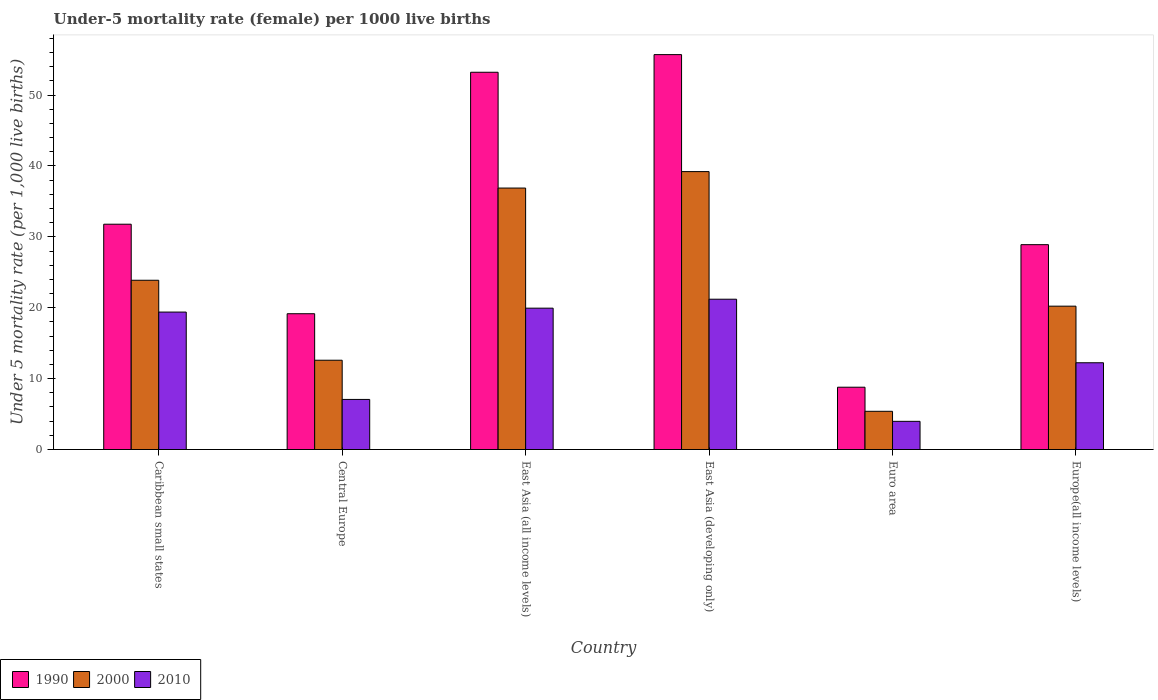How many groups of bars are there?
Make the answer very short. 6. Are the number of bars per tick equal to the number of legend labels?
Make the answer very short. Yes. How many bars are there on the 3rd tick from the left?
Keep it short and to the point. 3. How many bars are there on the 1st tick from the right?
Your response must be concise. 3. What is the label of the 4th group of bars from the left?
Your answer should be compact. East Asia (developing only). In how many cases, is the number of bars for a given country not equal to the number of legend labels?
Your answer should be very brief. 0. What is the under-five mortality rate in 1990 in Europe(all income levels)?
Ensure brevity in your answer.  28.9. Across all countries, what is the maximum under-five mortality rate in 1990?
Offer a very short reply. 55.7. Across all countries, what is the minimum under-five mortality rate in 2000?
Provide a short and direct response. 5.39. In which country was the under-five mortality rate in 1990 maximum?
Provide a succinct answer. East Asia (developing only). In which country was the under-five mortality rate in 2000 minimum?
Keep it short and to the point. Euro area. What is the total under-five mortality rate in 2000 in the graph?
Make the answer very short. 138.16. What is the difference between the under-five mortality rate in 1990 in Euro area and that in Europe(all income levels)?
Provide a succinct answer. -20.11. What is the difference between the under-five mortality rate in 2010 in East Asia (developing only) and the under-five mortality rate in 1990 in Euro area?
Ensure brevity in your answer.  12.41. What is the average under-five mortality rate in 2000 per country?
Your answer should be very brief. 23.03. What is the difference between the under-five mortality rate of/in 1990 and under-five mortality rate of/in 2000 in Europe(all income levels)?
Give a very brief answer. 8.68. In how many countries, is the under-five mortality rate in 2000 greater than 36?
Ensure brevity in your answer.  2. What is the ratio of the under-five mortality rate in 2010 in East Asia (all income levels) to that in Euro area?
Keep it short and to the point. 5.02. Is the under-five mortality rate in 1990 in Central Europe less than that in Europe(all income levels)?
Provide a short and direct response. Yes. What is the difference between the highest and the second highest under-five mortality rate in 1990?
Offer a terse response. -21.43. What is the difference between the highest and the lowest under-five mortality rate in 1990?
Give a very brief answer. 46.91. In how many countries, is the under-five mortality rate in 2000 greater than the average under-five mortality rate in 2000 taken over all countries?
Your answer should be compact. 3. What does the 2nd bar from the left in East Asia (all income levels) represents?
Offer a very short reply. 2000. What does the 3rd bar from the right in Central Europe represents?
Provide a short and direct response. 1990. Is it the case that in every country, the sum of the under-five mortality rate in 2000 and under-five mortality rate in 1990 is greater than the under-five mortality rate in 2010?
Make the answer very short. Yes. How many bars are there?
Provide a short and direct response. 18. How many countries are there in the graph?
Give a very brief answer. 6. What is the difference between two consecutive major ticks on the Y-axis?
Make the answer very short. 10. Does the graph contain any zero values?
Your answer should be compact. No. Does the graph contain grids?
Your answer should be compact. No. Where does the legend appear in the graph?
Keep it short and to the point. Bottom left. What is the title of the graph?
Offer a terse response. Under-5 mortality rate (female) per 1000 live births. Does "2005" appear as one of the legend labels in the graph?
Your answer should be compact. No. What is the label or title of the X-axis?
Your answer should be compact. Country. What is the label or title of the Y-axis?
Your answer should be compact. Under 5 mortality rate (per 1,0 live births). What is the Under 5 mortality rate (per 1,000 live births) in 1990 in Caribbean small states?
Give a very brief answer. 31.78. What is the Under 5 mortality rate (per 1,000 live births) in 2000 in Caribbean small states?
Give a very brief answer. 23.87. What is the Under 5 mortality rate (per 1,000 live births) in 2010 in Caribbean small states?
Your response must be concise. 19.39. What is the Under 5 mortality rate (per 1,000 live births) in 1990 in Central Europe?
Make the answer very short. 19.15. What is the Under 5 mortality rate (per 1,000 live births) in 2000 in Central Europe?
Provide a short and direct response. 12.6. What is the Under 5 mortality rate (per 1,000 live births) of 2010 in Central Europe?
Offer a very short reply. 7.06. What is the Under 5 mortality rate (per 1,000 live births) in 1990 in East Asia (all income levels)?
Your answer should be compact. 53.21. What is the Under 5 mortality rate (per 1,000 live births) of 2000 in East Asia (all income levels)?
Your response must be concise. 36.88. What is the Under 5 mortality rate (per 1,000 live births) in 2010 in East Asia (all income levels)?
Offer a terse response. 19.94. What is the Under 5 mortality rate (per 1,000 live births) in 1990 in East Asia (developing only)?
Give a very brief answer. 55.7. What is the Under 5 mortality rate (per 1,000 live births) in 2000 in East Asia (developing only)?
Provide a succinct answer. 39.2. What is the Under 5 mortality rate (per 1,000 live births) of 2010 in East Asia (developing only)?
Offer a terse response. 21.2. What is the Under 5 mortality rate (per 1,000 live births) in 1990 in Euro area?
Provide a succinct answer. 8.79. What is the Under 5 mortality rate (per 1,000 live births) of 2000 in Euro area?
Offer a very short reply. 5.39. What is the Under 5 mortality rate (per 1,000 live births) in 2010 in Euro area?
Keep it short and to the point. 3.97. What is the Under 5 mortality rate (per 1,000 live births) in 1990 in Europe(all income levels)?
Your response must be concise. 28.9. What is the Under 5 mortality rate (per 1,000 live births) in 2000 in Europe(all income levels)?
Provide a succinct answer. 20.22. What is the Under 5 mortality rate (per 1,000 live births) in 2010 in Europe(all income levels)?
Provide a short and direct response. 12.24. Across all countries, what is the maximum Under 5 mortality rate (per 1,000 live births) in 1990?
Keep it short and to the point. 55.7. Across all countries, what is the maximum Under 5 mortality rate (per 1,000 live births) of 2000?
Make the answer very short. 39.2. Across all countries, what is the maximum Under 5 mortality rate (per 1,000 live births) in 2010?
Ensure brevity in your answer.  21.2. Across all countries, what is the minimum Under 5 mortality rate (per 1,000 live births) of 1990?
Offer a very short reply. 8.79. Across all countries, what is the minimum Under 5 mortality rate (per 1,000 live births) in 2000?
Your response must be concise. 5.39. Across all countries, what is the minimum Under 5 mortality rate (per 1,000 live births) in 2010?
Keep it short and to the point. 3.97. What is the total Under 5 mortality rate (per 1,000 live births) in 1990 in the graph?
Your response must be concise. 197.53. What is the total Under 5 mortality rate (per 1,000 live births) of 2000 in the graph?
Make the answer very short. 138.16. What is the total Under 5 mortality rate (per 1,000 live births) in 2010 in the graph?
Provide a short and direct response. 83.8. What is the difference between the Under 5 mortality rate (per 1,000 live births) in 1990 in Caribbean small states and that in Central Europe?
Offer a terse response. 12.63. What is the difference between the Under 5 mortality rate (per 1,000 live births) in 2000 in Caribbean small states and that in Central Europe?
Keep it short and to the point. 11.28. What is the difference between the Under 5 mortality rate (per 1,000 live births) in 2010 in Caribbean small states and that in Central Europe?
Your answer should be compact. 12.32. What is the difference between the Under 5 mortality rate (per 1,000 live births) of 1990 in Caribbean small states and that in East Asia (all income levels)?
Your answer should be very brief. -21.43. What is the difference between the Under 5 mortality rate (per 1,000 live births) in 2000 in Caribbean small states and that in East Asia (all income levels)?
Provide a short and direct response. -13. What is the difference between the Under 5 mortality rate (per 1,000 live births) in 2010 in Caribbean small states and that in East Asia (all income levels)?
Provide a short and direct response. -0.55. What is the difference between the Under 5 mortality rate (per 1,000 live births) of 1990 in Caribbean small states and that in East Asia (developing only)?
Offer a terse response. -23.92. What is the difference between the Under 5 mortality rate (per 1,000 live births) of 2000 in Caribbean small states and that in East Asia (developing only)?
Offer a very short reply. -15.33. What is the difference between the Under 5 mortality rate (per 1,000 live births) of 2010 in Caribbean small states and that in East Asia (developing only)?
Your response must be concise. -1.81. What is the difference between the Under 5 mortality rate (per 1,000 live births) in 1990 in Caribbean small states and that in Euro area?
Ensure brevity in your answer.  22.99. What is the difference between the Under 5 mortality rate (per 1,000 live births) of 2000 in Caribbean small states and that in Euro area?
Offer a very short reply. 18.48. What is the difference between the Under 5 mortality rate (per 1,000 live births) of 2010 in Caribbean small states and that in Euro area?
Provide a short and direct response. 15.41. What is the difference between the Under 5 mortality rate (per 1,000 live births) in 1990 in Caribbean small states and that in Europe(all income levels)?
Make the answer very short. 2.88. What is the difference between the Under 5 mortality rate (per 1,000 live births) of 2000 in Caribbean small states and that in Europe(all income levels)?
Provide a succinct answer. 3.65. What is the difference between the Under 5 mortality rate (per 1,000 live births) in 2010 in Caribbean small states and that in Europe(all income levels)?
Offer a terse response. 7.15. What is the difference between the Under 5 mortality rate (per 1,000 live births) in 1990 in Central Europe and that in East Asia (all income levels)?
Offer a terse response. -34.06. What is the difference between the Under 5 mortality rate (per 1,000 live births) in 2000 in Central Europe and that in East Asia (all income levels)?
Provide a succinct answer. -24.28. What is the difference between the Under 5 mortality rate (per 1,000 live births) in 2010 in Central Europe and that in East Asia (all income levels)?
Provide a succinct answer. -12.87. What is the difference between the Under 5 mortality rate (per 1,000 live births) of 1990 in Central Europe and that in East Asia (developing only)?
Your response must be concise. -36.55. What is the difference between the Under 5 mortality rate (per 1,000 live births) of 2000 in Central Europe and that in East Asia (developing only)?
Offer a very short reply. -26.6. What is the difference between the Under 5 mortality rate (per 1,000 live births) of 2010 in Central Europe and that in East Asia (developing only)?
Give a very brief answer. -14.14. What is the difference between the Under 5 mortality rate (per 1,000 live births) of 1990 in Central Europe and that in Euro area?
Ensure brevity in your answer.  10.36. What is the difference between the Under 5 mortality rate (per 1,000 live births) in 2000 in Central Europe and that in Euro area?
Offer a very short reply. 7.21. What is the difference between the Under 5 mortality rate (per 1,000 live births) of 2010 in Central Europe and that in Euro area?
Make the answer very short. 3.09. What is the difference between the Under 5 mortality rate (per 1,000 live births) in 1990 in Central Europe and that in Europe(all income levels)?
Your answer should be very brief. -9.74. What is the difference between the Under 5 mortality rate (per 1,000 live births) of 2000 in Central Europe and that in Europe(all income levels)?
Make the answer very short. -7.62. What is the difference between the Under 5 mortality rate (per 1,000 live births) in 2010 in Central Europe and that in Europe(all income levels)?
Your answer should be very brief. -5.17. What is the difference between the Under 5 mortality rate (per 1,000 live births) in 1990 in East Asia (all income levels) and that in East Asia (developing only)?
Your answer should be compact. -2.49. What is the difference between the Under 5 mortality rate (per 1,000 live births) of 2000 in East Asia (all income levels) and that in East Asia (developing only)?
Your answer should be very brief. -2.32. What is the difference between the Under 5 mortality rate (per 1,000 live births) in 2010 in East Asia (all income levels) and that in East Asia (developing only)?
Give a very brief answer. -1.26. What is the difference between the Under 5 mortality rate (per 1,000 live births) in 1990 in East Asia (all income levels) and that in Euro area?
Provide a short and direct response. 44.42. What is the difference between the Under 5 mortality rate (per 1,000 live births) in 2000 in East Asia (all income levels) and that in Euro area?
Your response must be concise. 31.49. What is the difference between the Under 5 mortality rate (per 1,000 live births) in 2010 in East Asia (all income levels) and that in Euro area?
Make the answer very short. 15.96. What is the difference between the Under 5 mortality rate (per 1,000 live births) in 1990 in East Asia (all income levels) and that in Europe(all income levels)?
Keep it short and to the point. 24.32. What is the difference between the Under 5 mortality rate (per 1,000 live births) in 2000 in East Asia (all income levels) and that in Europe(all income levels)?
Provide a short and direct response. 16.66. What is the difference between the Under 5 mortality rate (per 1,000 live births) in 2010 in East Asia (all income levels) and that in Europe(all income levels)?
Make the answer very short. 7.7. What is the difference between the Under 5 mortality rate (per 1,000 live births) in 1990 in East Asia (developing only) and that in Euro area?
Give a very brief answer. 46.91. What is the difference between the Under 5 mortality rate (per 1,000 live births) in 2000 in East Asia (developing only) and that in Euro area?
Your response must be concise. 33.81. What is the difference between the Under 5 mortality rate (per 1,000 live births) of 2010 in East Asia (developing only) and that in Euro area?
Make the answer very short. 17.23. What is the difference between the Under 5 mortality rate (per 1,000 live births) in 1990 in East Asia (developing only) and that in Europe(all income levels)?
Give a very brief answer. 26.8. What is the difference between the Under 5 mortality rate (per 1,000 live births) of 2000 in East Asia (developing only) and that in Europe(all income levels)?
Your answer should be very brief. 18.98. What is the difference between the Under 5 mortality rate (per 1,000 live births) of 2010 in East Asia (developing only) and that in Europe(all income levels)?
Give a very brief answer. 8.96. What is the difference between the Under 5 mortality rate (per 1,000 live births) in 1990 in Euro area and that in Europe(all income levels)?
Give a very brief answer. -20.11. What is the difference between the Under 5 mortality rate (per 1,000 live births) in 2000 in Euro area and that in Europe(all income levels)?
Ensure brevity in your answer.  -14.83. What is the difference between the Under 5 mortality rate (per 1,000 live births) in 2010 in Euro area and that in Europe(all income levels)?
Offer a very short reply. -8.26. What is the difference between the Under 5 mortality rate (per 1,000 live births) in 1990 in Caribbean small states and the Under 5 mortality rate (per 1,000 live births) in 2000 in Central Europe?
Ensure brevity in your answer.  19.18. What is the difference between the Under 5 mortality rate (per 1,000 live births) of 1990 in Caribbean small states and the Under 5 mortality rate (per 1,000 live births) of 2010 in Central Europe?
Give a very brief answer. 24.72. What is the difference between the Under 5 mortality rate (per 1,000 live births) in 2000 in Caribbean small states and the Under 5 mortality rate (per 1,000 live births) in 2010 in Central Europe?
Provide a succinct answer. 16.81. What is the difference between the Under 5 mortality rate (per 1,000 live births) in 1990 in Caribbean small states and the Under 5 mortality rate (per 1,000 live births) in 2000 in East Asia (all income levels)?
Your answer should be compact. -5.1. What is the difference between the Under 5 mortality rate (per 1,000 live births) of 1990 in Caribbean small states and the Under 5 mortality rate (per 1,000 live births) of 2010 in East Asia (all income levels)?
Make the answer very short. 11.84. What is the difference between the Under 5 mortality rate (per 1,000 live births) of 2000 in Caribbean small states and the Under 5 mortality rate (per 1,000 live births) of 2010 in East Asia (all income levels)?
Give a very brief answer. 3.94. What is the difference between the Under 5 mortality rate (per 1,000 live births) in 1990 in Caribbean small states and the Under 5 mortality rate (per 1,000 live births) in 2000 in East Asia (developing only)?
Provide a succinct answer. -7.42. What is the difference between the Under 5 mortality rate (per 1,000 live births) in 1990 in Caribbean small states and the Under 5 mortality rate (per 1,000 live births) in 2010 in East Asia (developing only)?
Keep it short and to the point. 10.58. What is the difference between the Under 5 mortality rate (per 1,000 live births) of 2000 in Caribbean small states and the Under 5 mortality rate (per 1,000 live births) of 2010 in East Asia (developing only)?
Your answer should be very brief. 2.67. What is the difference between the Under 5 mortality rate (per 1,000 live births) in 1990 in Caribbean small states and the Under 5 mortality rate (per 1,000 live births) in 2000 in Euro area?
Offer a very short reply. 26.39. What is the difference between the Under 5 mortality rate (per 1,000 live births) of 1990 in Caribbean small states and the Under 5 mortality rate (per 1,000 live births) of 2010 in Euro area?
Give a very brief answer. 27.8. What is the difference between the Under 5 mortality rate (per 1,000 live births) in 2000 in Caribbean small states and the Under 5 mortality rate (per 1,000 live births) in 2010 in Euro area?
Ensure brevity in your answer.  19.9. What is the difference between the Under 5 mortality rate (per 1,000 live births) of 1990 in Caribbean small states and the Under 5 mortality rate (per 1,000 live births) of 2000 in Europe(all income levels)?
Keep it short and to the point. 11.56. What is the difference between the Under 5 mortality rate (per 1,000 live births) in 1990 in Caribbean small states and the Under 5 mortality rate (per 1,000 live births) in 2010 in Europe(all income levels)?
Provide a succinct answer. 19.54. What is the difference between the Under 5 mortality rate (per 1,000 live births) in 2000 in Caribbean small states and the Under 5 mortality rate (per 1,000 live births) in 2010 in Europe(all income levels)?
Keep it short and to the point. 11.64. What is the difference between the Under 5 mortality rate (per 1,000 live births) of 1990 in Central Europe and the Under 5 mortality rate (per 1,000 live births) of 2000 in East Asia (all income levels)?
Your answer should be compact. -17.73. What is the difference between the Under 5 mortality rate (per 1,000 live births) in 1990 in Central Europe and the Under 5 mortality rate (per 1,000 live births) in 2010 in East Asia (all income levels)?
Offer a very short reply. -0.78. What is the difference between the Under 5 mortality rate (per 1,000 live births) of 2000 in Central Europe and the Under 5 mortality rate (per 1,000 live births) of 2010 in East Asia (all income levels)?
Keep it short and to the point. -7.34. What is the difference between the Under 5 mortality rate (per 1,000 live births) of 1990 in Central Europe and the Under 5 mortality rate (per 1,000 live births) of 2000 in East Asia (developing only)?
Your response must be concise. -20.05. What is the difference between the Under 5 mortality rate (per 1,000 live births) of 1990 in Central Europe and the Under 5 mortality rate (per 1,000 live births) of 2010 in East Asia (developing only)?
Provide a succinct answer. -2.05. What is the difference between the Under 5 mortality rate (per 1,000 live births) of 2000 in Central Europe and the Under 5 mortality rate (per 1,000 live births) of 2010 in East Asia (developing only)?
Keep it short and to the point. -8.6. What is the difference between the Under 5 mortality rate (per 1,000 live births) in 1990 in Central Europe and the Under 5 mortality rate (per 1,000 live births) in 2000 in Euro area?
Your answer should be very brief. 13.76. What is the difference between the Under 5 mortality rate (per 1,000 live births) of 1990 in Central Europe and the Under 5 mortality rate (per 1,000 live births) of 2010 in Euro area?
Ensure brevity in your answer.  15.18. What is the difference between the Under 5 mortality rate (per 1,000 live births) of 2000 in Central Europe and the Under 5 mortality rate (per 1,000 live births) of 2010 in Euro area?
Provide a short and direct response. 8.62. What is the difference between the Under 5 mortality rate (per 1,000 live births) of 1990 in Central Europe and the Under 5 mortality rate (per 1,000 live births) of 2000 in Europe(all income levels)?
Offer a very short reply. -1.07. What is the difference between the Under 5 mortality rate (per 1,000 live births) of 1990 in Central Europe and the Under 5 mortality rate (per 1,000 live births) of 2010 in Europe(all income levels)?
Your response must be concise. 6.92. What is the difference between the Under 5 mortality rate (per 1,000 live births) of 2000 in Central Europe and the Under 5 mortality rate (per 1,000 live births) of 2010 in Europe(all income levels)?
Make the answer very short. 0.36. What is the difference between the Under 5 mortality rate (per 1,000 live births) in 1990 in East Asia (all income levels) and the Under 5 mortality rate (per 1,000 live births) in 2000 in East Asia (developing only)?
Keep it short and to the point. 14.01. What is the difference between the Under 5 mortality rate (per 1,000 live births) of 1990 in East Asia (all income levels) and the Under 5 mortality rate (per 1,000 live births) of 2010 in East Asia (developing only)?
Your answer should be compact. 32.01. What is the difference between the Under 5 mortality rate (per 1,000 live births) in 2000 in East Asia (all income levels) and the Under 5 mortality rate (per 1,000 live births) in 2010 in East Asia (developing only)?
Provide a short and direct response. 15.68. What is the difference between the Under 5 mortality rate (per 1,000 live births) in 1990 in East Asia (all income levels) and the Under 5 mortality rate (per 1,000 live births) in 2000 in Euro area?
Ensure brevity in your answer.  47.82. What is the difference between the Under 5 mortality rate (per 1,000 live births) of 1990 in East Asia (all income levels) and the Under 5 mortality rate (per 1,000 live births) of 2010 in Euro area?
Provide a succinct answer. 49.24. What is the difference between the Under 5 mortality rate (per 1,000 live births) of 2000 in East Asia (all income levels) and the Under 5 mortality rate (per 1,000 live births) of 2010 in Euro area?
Make the answer very short. 32.9. What is the difference between the Under 5 mortality rate (per 1,000 live births) in 1990 in East Asia (all income levels) and the Under 5 mortality rate (per 1,000 live births) in 2000 in Europe(all income levels)?
Provide a short and direct response. 32.99. What is the difference between the Under 5 mortality rate (per 1,000 live births) in 1990 in East Asia (all income levels) and the Under 5 mortality rate (per 1,000 live births) in 2010 in Europe(all income levels)?
Your response must be concise. 40.97. What is the difference between the Under 5 mortality rate (per 1,000 live births) of 2000 in East Asia (all income levels) and the Under 5 mortality rate (per 1,000 live births) of 2010 in Europe(all income levels)?
Offer a very short reply. 24.64. What is the difference between the Under 5 mortality rate (per 1,000 live births) in 1990 in East Asia (developing only) and the Under 5 mortality rate (per 1,000 live births) in 2000 in Euro area?
Make the answer very short. 50.31. What is the difference between the Under 5 mortality rate (per 1,000 live births) in 1990 in East Asia (developing only) and the Under 5 mortality rate (per 1,000 live births) in 2010 in Euro area?
Offer a terse response. 51.73. What is the difference between the Under 5 mortality rate (per 1,000 live births) in 2000 in East Asia (developing only) and the Under 5 mortality rate (per 1,000 live births) in 2010 in Euro area?
Your answer should be very brief. 35.23. What is the difference between the Under 5 mortality rate (per 1,000 live births) in 1990 in East Asia (developing only) and the Under 5 mortality rate (per 1,000 live births) in 2000 in Europe(all income levels)?
Provide a succinct answer. 35.48. What is the difference between the Under 5 mortality rate (per 1,000 live births) of 1990 in East Asia (developing only) and the Under 5 mortality rate (per 1,000 live births) of 2010 in Europe(all income levels)?
Make the answer very short. 43.46. What is the difference between the Under 5 mortality rate (per 1,000 live births) of 2000 in East Asia (developing only) and the Under 5 mortality rate (per 1,000 live births) of 2010 in Europe(all income levels)?
Offer a very short reply. 26.96. What is the difference between the Under 5 mortality rate (per 1,000 live births) of 1990 in Euro area and the Under 5 mortality rate (per 1,000 live births) of 2000 in Europe(all income levels)?
Make the answer very short. -11.43. What is the difference between the Under 5 mortality rate (per 1,000 live births) of 1990 in Euro area and the Under 5 mortality rate (per 1,000 live births) of 2010 in Europe(all income levels)?
Your answer should be compact. -3.45. What is the difference between the Under 5 mortality rate (per 1,000 live births) of 2000 in Euro area and the Under 5 mortality rate (per 1,000 live births) of 2010 in Europe(all income levels)?
Your response must be concise. -6.85. What is the average Under 5 mortality rate (per 1,000 live births) in 1990 per country?
Make the answer very short. 32.92. What is the average Under 5 mortality rate (per 1,000 live births) in 2000 per country?
Ensure brevity in your answer.  23.03. What is the average Under 5 mortality rate (per 1,000 live births) of 2010 per country?
Provide a short and direct response. 13.97. What is the difference between the Under 5 mortality rate (per 1,000 live births) of 1990 and Under 5 mortality rate (per 1,000 live births) of 2000 in Caribbean small states?
Offer a terse response. 7.9. What is the difference between the Under 5 mortality rate (per 1,000 live births) in 1990 and Under 5 mortality rate (per 1,000 live births) in 2010 in Caribbean small states?
Make the answer very short. 12.39. What is the difference between the Under 5 mortality rate (per 1,000 live births) of 2000 and Under 5 mortality rate (per 1,000 live births) of 2010 in Caribbean small states?
Provide a short and direct response. 4.49. What is the difference between the Under 5 mortality rate (per 1,000 live births) in 1990 and Under 5 mortality rate (per 1,000 live births) in 2000 in Central Europe?
Ensure brevity in your answer.  6.56. What is the difference between the Under 5 mortality rate (per 1,000 live births) of 1990 and Under 5 mortality rate (per 1,000 live births) of 2010 in Central Europe?
Provide a short and direct response. 12.09. What is the difference between the Under 5 mortality rate (per 1,000 live births) of 2000 and Under 5 mortality rate (per 1,000 live births) of 2010 in Central Europe?
Provide a succinct answer. 5.53. What is the difference between the Under 5 mortality rate (per 1,000 live births) of 1990 and Under 5 mortality rate (per 1,000 live births) of 2000 in East Asia (all income levels)?
Give a very brief answer. 16.33. What is the difference between the Under 5 mortality rate (per 1,000 live births) in 1990 and Under 5 mortality rate (per 1,000 live births) in 2010 in East Asia (all income levels)?
Keep it short and to the point. 33.27. What is the difference between the Under 5 mortality rate (per 1,000 live births) of 2000 and Under 5 mortality rate (per 1,000 live births) of 2010 in East Asia (all income levels)?
Offer a very short reply. 16.94. What is the difference between the Under 5 mortality rate (per 1,000 live births) in 1990 and Under 5 mortality rate (per 1,000 live births) in 2010 in East Asia (developing only)?
Ensure brevity in your answer.  34.5. What is the difference between the Under 5 mortality rate (per 1,000 live births) of 2000 and Under 5 mortality rate (per 1,000 live births) of 2010 in East Asia (developing only)?
Provide a short and direct response. 18. What is the difference between the Under 5 mortality rate (per 1,000 live births) of 1990 and Under 5 mortality rate (per 1,000 live births) of 2000 in Euro area?
Offer a very short reply. 3.4. What is the difference between the Under 5 mortality rate (per 1,000 live births) of 1990 and Under 5 mortality rate (per 1,000 live births) of 2010 in Euro area?
Make the answer very short. 4.81. What is the difference between the Under 5 mortality rate (per 1,000 live births) in 2000 and Under 5 mortality rate (per 1,000 live births) in 2010 in Euro area?
Make the answer very short. 1.42. What is the difference between the Under 5 mortality rate (per 1,000 live births) in 1990 and Under 5 mortality rate (per 1,000 live births) in 2000 in Europe(all income levels)?
Provide a succinct answer. 8.68. What is the difference between the Under 5 mortality rate (per 1,000 live births) in 1990 and Under 5 mortality rate (per 1,000 live births) in 2010 in Europe(all income levels)?
Provide a succinct answer. 16.66. What is the difference between the Under 5 mortality rate (per 1,000 live births) in 2000 and Under 5 mortality rate (per 1,000 live births) in 2010 in Europe(all income levels)?
Keep it short and to the point. 7.98. What is the ratio of the Under 5 mortality rate (per 1,000 live births) of 1990 in Caribbean small states to that in Central Europe?
Provide a succinct answer. 1.66. What is the ratio of the Under 5 mortality rate (per 1,000 live births) in 2000 in Caribbean small states to that in Central Europe?
Offer a very short reply. 1.9. What is the ratio of the Under 5 mortality rate (per 1,000 live births) in 2010 in Caribbean small states to that in Central Europe?
Offer a terse response. 2.74. What is the ratio of the Under 5 mortality rate (per 1,000 live births) in 1990 in Caribbean small states to that in East Asia (all income levels)?
Your answer should be very brief. 0.6. What is the ratio of the Under 5 mortality rate (per 1,000 live births) of 2000 in Caribbean small states to that in East Asia (all income levels)?
Offer a terse response. 0.65. What is the ratio of the Under 5 mortality rate (per 1,000 live births) of 2010 in Caribbean small states to that in East Asia (all income levels)?
Offer a terse response. 0.97. What is the ratio of the Under 5 mortality rate (per 1,000 live births) in 1990 in Caribbean small states to that in East Asia (developing only)?
Your response must be concise. 0.57. What is the ratio of the Under 5 mortality rate (per 1,000 live births) of 2000 in Caribbean small states to that in East Asia (developing only)?
Provide a succinct answer. 0.61. What is the ratio of the Under 5 mortality rate (per 1,000 live births) of 2010 in Caribbean small states to that in East Asia (developing only)?
Ensure brevity in your answer.  0.91. What is the ratio of the Under 5 mortality rate (per 1,000 live births) of 1990 in Caribbean small states to that in Euro area?
Keep it short and to the point. 3.62. What is the ratio of the Under 5 mortality rate (per 1,000 live births) of 2000 in Caribbean small states to that in Euro area?
Keep it short and to the point. 4.43. What is the ratio of the Under 5 mortality rate (per 1,000 live births) in 2010 in Caribbean small states to that in Euro area?
Provide a short and direct response. 4.88. What is the ratio of the Under 5 mortality rate (per 1,000 live births) of 1990 in Caribbean small states to that in Europe(all income levels)?
Make the answer very short. 1.1. What is the ratio of the Under 5 mortality rate (per 1,000 live births) in 2000 in Caribbean small states to that in Europe(all income levels)?
Your answer should be very brief. 1.18. What is the ratio of the Under 5 mortality rate (per 1,000 live births) in 2010 in Caribbean small states to that in Europe(all income levels)?
Offer a terse response. 1.58. What is the ratio of the Under 5 mortality rate (per 1,000 live births) in 1990 in Central Europe to that in East Asia (all income levels)?
Give a very brief answer. 0.36. What is the ratio of the Under 5 mortality rate (per 1,000 live births) in 2000 in Central Europe to that in East Asia (all income levels)?
Provide a short and direct response. 0.34. What is the ratio of the Under 5 mortality rate (per 1,000 live births) of 2010 in Central Europe to that in East Asia (all income levels)?
Your answer should be very brief. 0.35. What is the ratio of the Under 5 mortality rate (per 1,000 live births) in 1990 in Central Europe to that in East Asia (developing only)?
Ensure brevity in your answer.  0.34. What is the ratio of the Under 5 mortality rate (per 1,000 live births) in 2000 in Central Europe to that in East Asia (developing only)?
Offer a very short reply. 0.32. What is the ratio of the Under 5 mortality rate (per 1,000 live births) in 2010 in Central Europe to that in East Asia (developing only)?
Make the answer very short. 0.33. What is the ratio of the Under 5 mortality rate (per 1,000 live births) in 1990 in Central Europe to that in Euro area?
Offer a terse response. 2.18. What is the ratio of the Under 5 mortality rate (per 1,000 live births) in 2000 in Central Europe to that in Euro area?
Keep it short and to the point. 2.34. What is the ratio of the Under 5 mortality rate (per 1,000 live births) in 2010 in Central Europe to that in Euro area?
Your response must be concise. 1.78. What is the ratio of the Under 5 mortality rate (per 1,000 live births) of 1990 in Central Europe to that in Europe(all income levels)?
Your answer should be compact. 0.66. What is the ratio of the Under 5 mortality rate (per 1,000 live births) of 2000 in Central Europe to that in Europe(all income levels)?
Provide a short and direct response. 0.62. What is the ratio of the Under 5 mortality rate (per 1,000 live births) of 2010 in Central Europe to that in Europe(all income levels)?
Ensure brevity in your answer.  0.58. What is the ratio of the Under 5 mortality rate (per 1,000 live births) in 1990 in East Asia (all income levels) to that in East Asia (developing only)?
Your response must be concise. 0.96. What is the ratio of the Under 5 mortality rate (per 1,000 live births) in 2000 in East Asia (all income levels) to that in East Asia (developing only)?
Offer a terse response. 0.94. What is the ratio of the Under 5 mortality rate (per 1,000 live births) of 2010 in East Asia (all income levels) to that in East Asia (developing only)?
Offer a terse response. 0.94. What is the ratio of the Under 5 mortality rate (per 1,000 live births) in 1990 in East Asia (all income levels) to that in Euro area?
Ensure brevity in your answer.  6.05. What is the ratio of the Under 5 mortality rate (per 1,000 live births) in 2000 in East Asia (all income levels) to that in Euro area?
Offer a very short reply. 6.84. What is the ratio of the Under 5 mortality rate (per 1,000 live births) of 2010 in East Asia (all income levels) to that in Euro area?
Keep it short and to the point. 5.02. What is the ratio of the Under 5 mortality rate (per 1,000 live births) in 1990 in East Asia (all income levels) to that in Europe(all income levels)?
Your response must be concise. 1.84. What is the ratio of the Under 5 mortality rate (per 1,000 live births) of 2000 in East Asia (all income levels) to that in Europe(all income levels)?
Your response must be concise. 1.82. What is the ratio of the Under 5 mortality rate (per 1,000 live births) of 2010 in East Asia (all income levels) to that in Europe(all income levels)?
Your answer should be compact. 1.63. What is the ratio of the Under 5 mortality rate (per 1,000 live births) in 1990 in East Asia (developing only) to that in Euro area?
Your answer should be compact. 6.34. What is the ratio of the Under 5 mortality rate (per 1,000 live births) of 2000 in East Asia (developing only) to that in Euro area?
Ensure brevity in your answer.  7.27. What is the ratio of the Under 5 mortality rate (per 1,000 live births) in 2010 in East Asia (developing only) to that in Euro area?
Offer a very short reply. 5.33. What is the ratio of the Under 5 mortality rate (per 1,000 live births) in 1990 in East Asia (developing only) to that in Europe(all income levels)?
Provide a succinct answer. 1.93. What is the ratio of the Under 5 mortality rate (per 1,000 live births) of 2000 in East Asia (developing only) to that in Europe(all income levels)?
Ensure brevity in your answer.  1.94. What is the ratio of the Under 5 mortality rate (per 1,000 live births) in 2010 in East Asia (developing only) to that in Europe(all income levels)?
Offer a terse response. 1.73. What is the ratio of the Under 5 mortality rate (per 1,000 live births) of 1990 in Euro area to that in Europe(all income levels)?
Your answer should be compact. 0.3. What is the ratio of the Under 5 mortality rate (per 1,000 live births) of 2000 in Euro area to that in Europe(all income levels)?
Ensure brevity in your answer.  0.27. What is the ratio of the Under 5 mortality rate (per 1,000 live births) in 2010 in Euro area to that in Europe(all income levels)?
Ensure brevity in your answer.  0.32. What is the difference between the highest and the second highest Under 5 mortality rate (per 1,000 live births) in 1990?
Provide a short and direct response. 2.49. What is the difference between the highest and the second highest Under 5 mortality rate (per 1,000 live births) in 2000?
Give a very brief answer. 2.32. What is the difference between the highest and the second highest Under 5 mortality rate (per 1,000 live births) in 2010?
Ensure brevity in your answer.  1.26. What is the difference between the highest and the lowest Under 5 mortality rate (per 1,000 live births) in 1990?
Your answer should be compact. 46.91. What is the difference between the highest and the lowest Under 5 mortality rate (per 1,000 live births) in 2000?
Make the answer very short. 33.81. What is the difference between the highest and the lowest Under 5 mortality rate (per 1,000 live births) of 2010?
Make the answer very short. 17.23. 